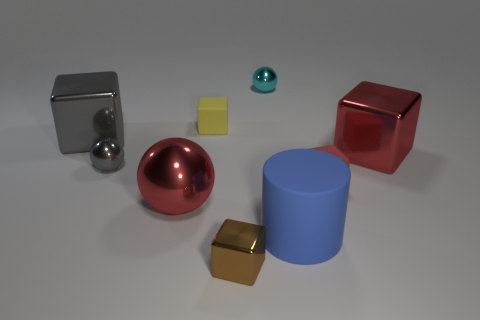There is a big object that is the same color as the large metallic sphere; what is its material?
Provide a short and direct response. Metal. How many objects are either metal blocks or cubes behind the brown metallic thing?
Give a very brief answer. 5. What material is the cylinder?
Ensure brevity in your answer.  Rubber. What material is the tiny red object that is the same shape as the brown shiny object?
Offer a very short reply. Rubber. There is a small matte object that is to the right of the brown metallic object that is in front of the tiny red matte cube; what is its color?
Give a very brief answer. Red. What number of shiny objects are either red spheres or cyan balls?
Offer a very short reply. 2. Is the material of the tiny red object the same as the big cylinder?
Keep it short and to the point. Yes. The cylinder on the right side of the red metallic thing on the left side of the small brown shiny object is made of what material?
Your response must be concise. Rubber. What number of big things are either gray metal balls or red metallic cylinders?
Keep it short and to the point. 0. The red metal block is what size?
Offer a terse response. Large. 